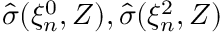<formula> <loc_0><loc_0><loc_500><loc_500>\hat { \sigma } ( \xi _ { n } ^ { 0 } , Z ) , \hat { \sigma } ( \xi _ { n } ^ { 2 } , Z )</formula> 